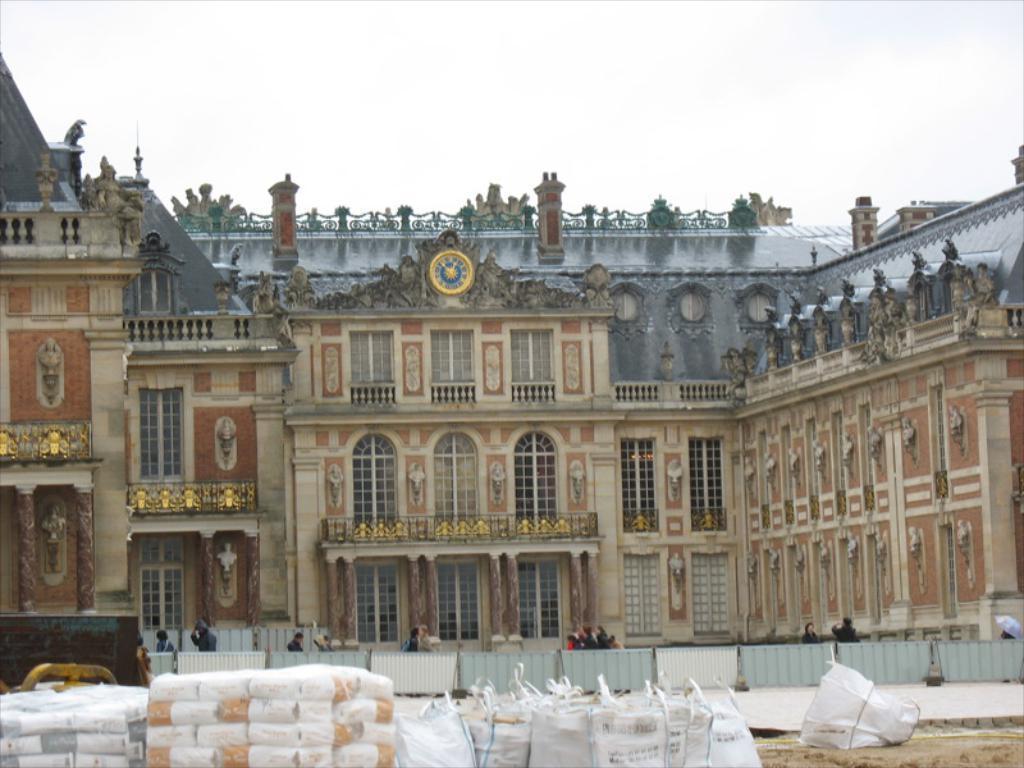Could you give a brief overview of what you see in this image? There is a building and there are few people and some other objects in front of it. 